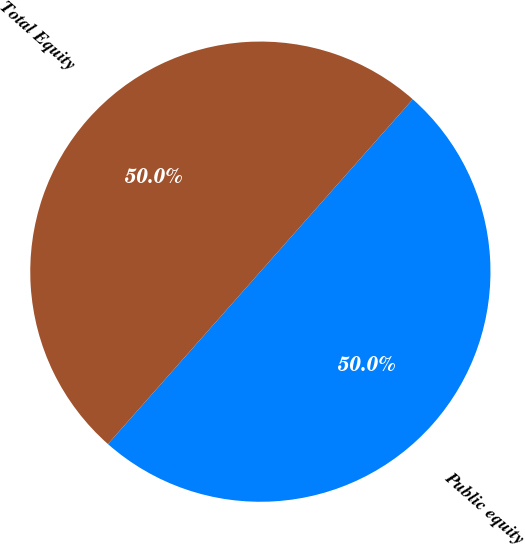Convert chart to OTSL. <chart><loc_0><loc_0><loc_500><loc_500><pie_chart><fcel>Public equity<fcel>Total Equity<nl><fcel>50.0%<fcel>50.0%<nl></chart> 